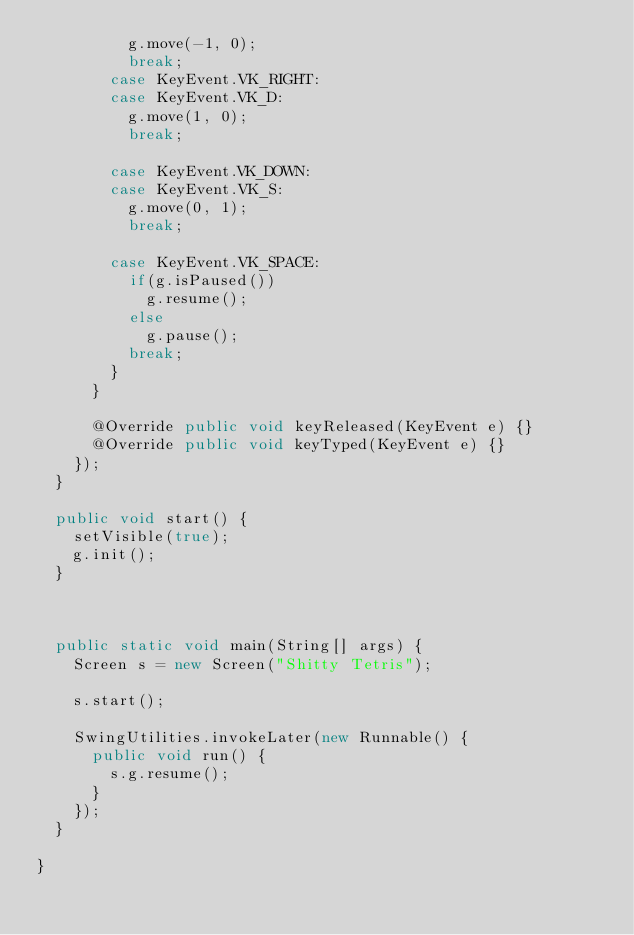Convert code to text. <code><loc_0><loc_0><loc_500><loc_500><_Java_>					g.move(-1, 0);
					break;
				case KeyEvent.VK_RIGHT:
				case KeyEvent.VK_D:
					g.move(1, 0);
					break;
					
				case KeyEvent.VK_DOWN:
				case KeyEvent.VK_S:
					g.move(0, 1);
					break;
					
				case KeyEvent.VK_SPACE:
					if(g.isPaused())
						g.resume();
					else
						g.pause();
					break;
				}
			}

			@Override public void keyReleased(KeyEvent e) {}
			@Override public void keyTyped(KeyEvent e) {}
		});
	}

	public void start() {
		setVisible(true);
		g.init();
	}

	

	public static void main(String[] args) {
		Screen s = new Screen("Shitty Tetris");

		s.start();

		SwingUtilities.invokeLater(new Runnable() {
			public void run() {
				s.g.resume();
			}
		});
	}

}
</code> 